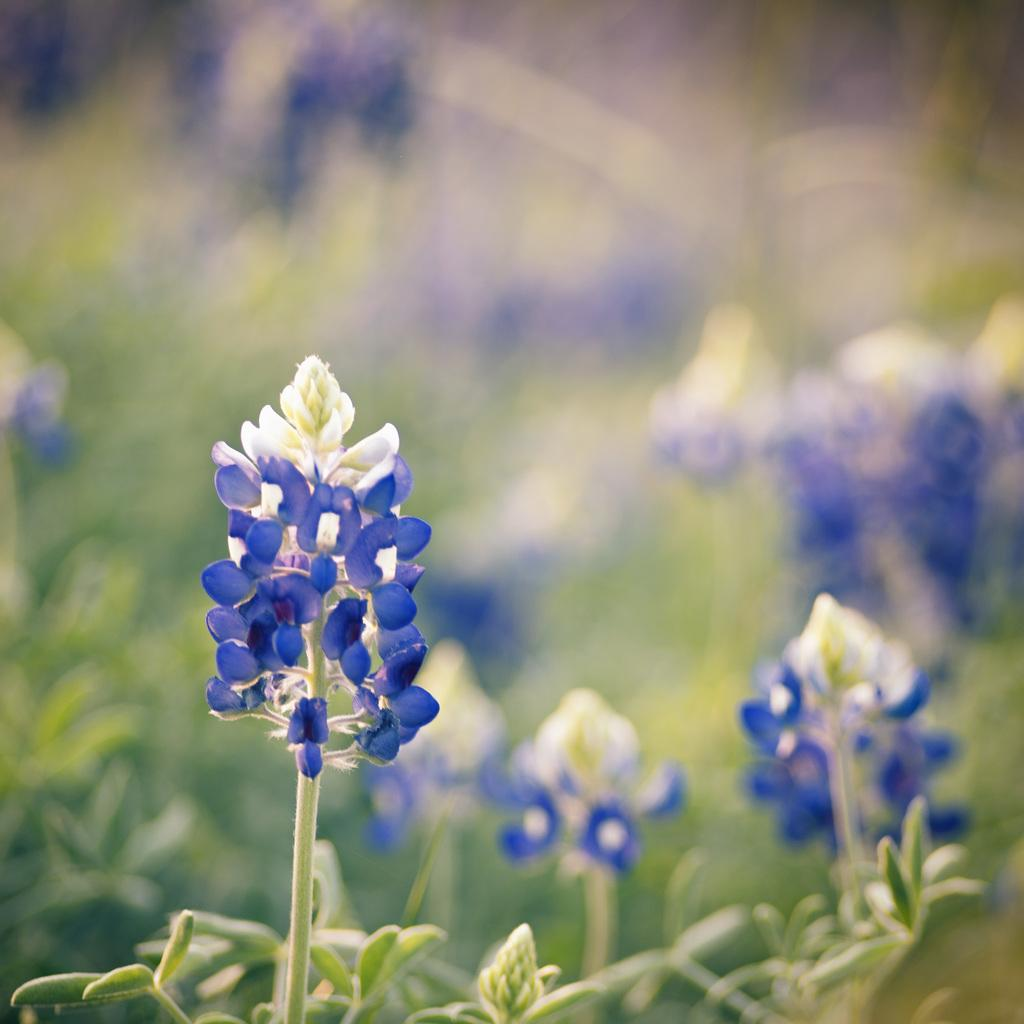What type of plant life is visible in the image? There are flowers, buds, and leaves visible in the image. Can you describe the background of the image? The background of the image is blurry. What type of hole can be seen in the image? There is no hole present in the image. What color is the gold ring in the image? There is no gold ring present in the image. 